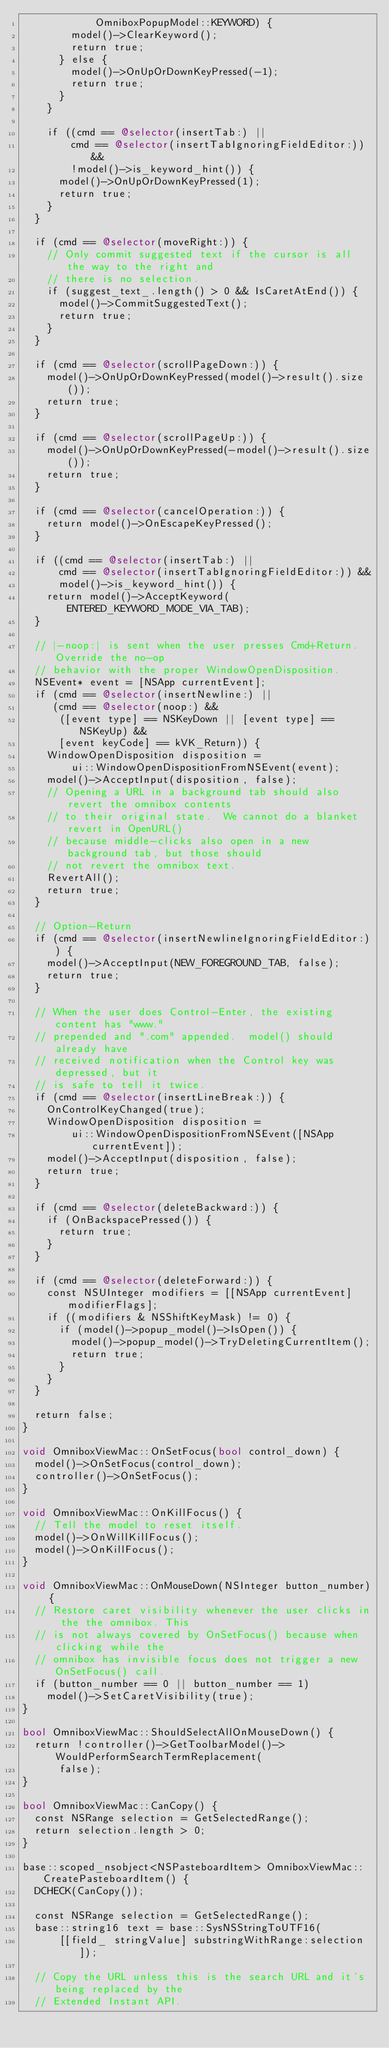Convert code to text. <code><loc_0><loc_0><loc_500><loc_500><_ObjectiveC_>            OmniboxPopupModel::KEYWORD) {
        model()->ClearKeyword();
        return true;
      } else {
        model()->OnUpOrDownKeyPressed(-1);
        return true;
      }
    }

    if ((cmd == @selector(insertTab:) ||
        cmd == @selector(insertTabIgnoringFieldEditor:)) &&
        !model()->is_keyword_hint()) {
      model()->OnUpOrDownKeyPressed(1);
      return true;
    }
  }

  if (cmd == @selector(moveRight:)) {
    // Only commit suggested text if the cursor is all the way to the right and
    // there is no selection.
    if (suggest_text_.length() > 0 && IsCaretAtEnd()) {
      model()->CommitSuggestedText();
      return true;
    }
  }

  if (cmd == @selector(scrollPageDown:)) {
    model()->OnUpOrDownKeyPressed(model()->result().size());
    return true;
  }

  if (cmd == @selector(scrollPageUp:)) {
    model()->OnUpOrDownKeyPressed(-model()->result().size());
    return true;
  }

  if (cmd == @selector(cancelOperation:)) {
    return model()->OnEscapeKeyPressed();
  }

  if ((cmd == @selector(insertTab:) ||
      cmd == @selector(insertTabIgnoringFieldEditor:)) &&
      model()->is_keyword_hint()) {
    return model()->AcceptKeyword(ENTERED_KEYWORD_MODE_VIA_TAB);
  }

  // |-noop:| is sent when the user presses Cmd+Return. Override the no-op
  // behavior with the proper WindowOpenDisposition.
  NSEvent* event = [NSApp currentEvent];
  if (cmd == @selector(insertNewline:) ||
     (cmd == @selector(noop:) &&
      ([event type] == NSKeyDown || [event type] == NSKeyUp) &&
      [event keyCode] == kVK_Return)) {
    WindowOpenDisposition disposition =
        ui::WindowOpenDispositionFromNSEvent(event);
    model()->AcceptInput(disposition, false);
    // Opening a URL in a background tab should also revert the omnibox contents
    // to their original state.  We cannot do a blanket revert in OpenURL()
    // because middle-clicks also open in a new background tab, but those should
    // not revert the omnibox text.
    RevertAll();
    return true;
  }

  // Option-Return
  if (cmd == @selector(insertNewlineIgnoringFieldEditor:)) {
    model()->AcceptInput(NEW_FOREGROUND_TAB, false);
    return true;
  }

  // When the user does Control-Enter, the existing content has "www."
  // prepended and ".com" appended.  model() should already have
  // received notification when the Control key was depressed, but it
  // is safe to tell it twice.
  if (cmd == @selector(insertLineBreak:)) {
    OnControlKeyChanged(true);
    WindowOpenDisposition disposition =
        ui::WindowOpenDispositionFromNSEvent([NSApp currentEvent]);
    model()->AcceptInput(disposition, false);
    return true;
  }

  if (cmd == @selector(deleteBackward:)) {
    if (OnBackspacePressed()) {
      return true;
    }
  }

  if (cmd == @selector(deleteForward:)) {
    const NSUInteger modifiers = [[NSApp currentEvent] modifierFlags];
    if ((modifiers & NSShiftKeyMask) != 0) {
      if (model()->popup_model()->IsOpen()) {
        model()->popup_model()->TryDeletingCurrentItem();
        return true;
      }
    }
  }

  return false;
}

void OmniboxViewMac::OnSetFocus(bool control_down) {
  model()->OnSetFocus(control_down);
  controller()->OnSetFocus();
}

void OmniboxViewMac::OnKillFocus() {
  // Tell the model to reset itself.
  model()->OnWillKillFocus();
  model()->OnKillFocus();
}

void OmniboxViewMac::OnMouseDown(NSInteger button_number) {
  // Restore caret visibility whenever the user clicks in the the omnibox. This
  // is not always covered by OnSetFocus() because when clicking while the
  // omnibox has invisible focus does not trigger a new OnSetFocus() call.
  if (button_number == 0 || button_number == 1)
    model()->SetCaretVisibility(true);
}

bool OmniboxViewMac::ShouldSelectAllOnMouseDown() {
  return !controller()->GetToolbarModel()->WouldPerformSearchTermReplacement(
      false);
}

bool OmniboxViewMac::CanCopy() {
  const NSRange selection = GetSelectedRange();
  return selection.length > 0;
}

base::scoped_nsobject<NSPasteboardItem> OmniboxViewMac::CreatePasteboardItem() {
  DCHECK(CanCopy());

  const NSRange selection = GetSelectedRange();
  base::string16 text = base::SysNSStringToUTF16(
      [[field_ stringValue] substringWithRange:selection]);

  // Copy the URL unless this is the search URL and it's being replaced by the
  // Extended Instant API.</code> 